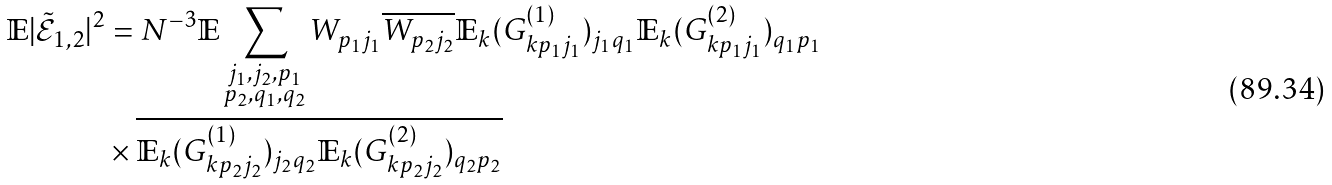Convert formula to latex. <formula><loc_0><loc_0><loc_500><loc_500>\mathbb { E } | \tilde { \mathcal { E } } _ { 1 , 2 } | ^ { 2 } & = N ^ { - 3 } \mathbb { E } \sum _ { \substack { j _ { 1 } , j _ { 2 } , p _ { 1 } \\ p _ { 2 } , q _ { 1 } , q _ { 2 } } } W _ { p _ { 1 } j _ { 1 } } \overline { W _ { p _ { 2 } j _ { 2 } } } \mathbb { E } _ { k } ( G ^ { ( 1 ) } _ { k p _ { 1 } j _ { 1 } } ) _ { j _ { 1 } q _ { 1 } } \mathbb { E } _ { k } ( G ^ { ( 2 ) } _ { k p _ { 1 } j _ { 1 } } ) _ { q _ { 1 } p _ { 1 } } \\ & \times \overline { \mathbb { E } _ { k } ( G ^ { ( 1 ) } _ { k p _ { 2 } j _ { 2 } } ) _ { j _ { 2 } q _ { 2 } } } \overline { \mathbb { E } _ { k } ( G ^ { ( 2 ) } _ { k p _ { 2 } j _ { 2 } } ) _ { q _ { 2 } p _ { 2 } } }</formula> 